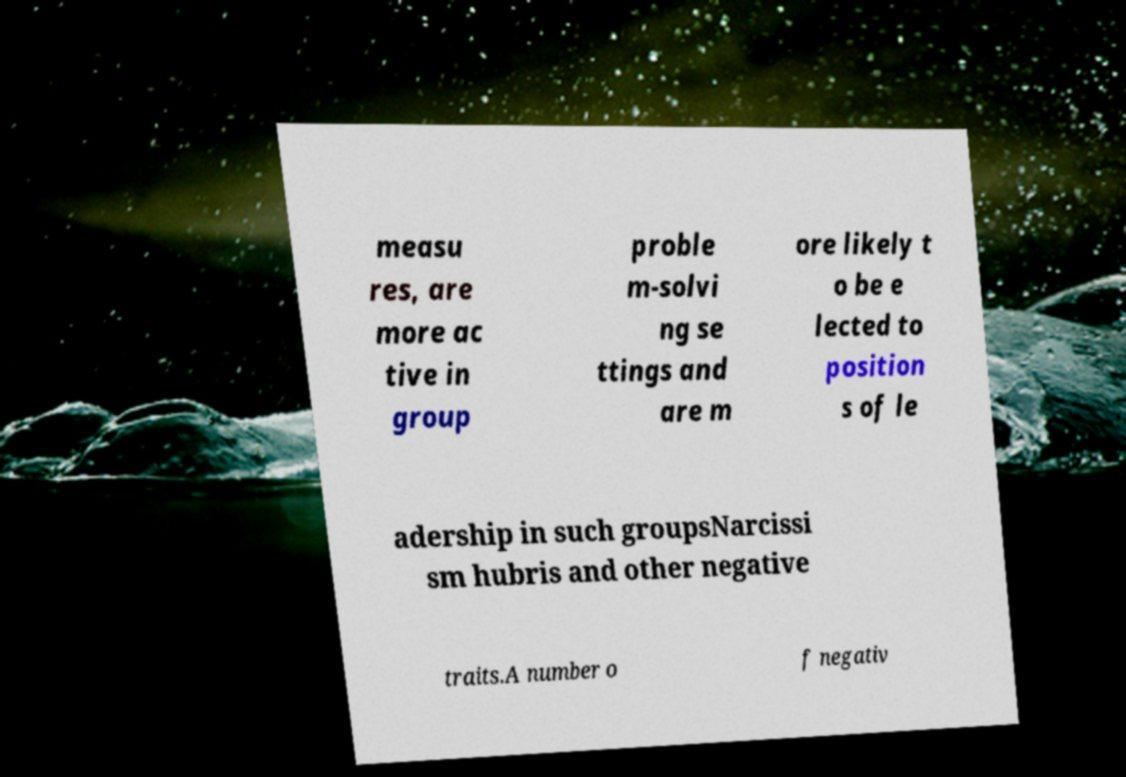Can you accurately transcribe the text from the provided image for me? measu res, are more ac tive in group proble m-solvi ng se ttings and are m ore likely t o be e lected to position s of le adership in such groupsNarcissi sm hubris and other negative traits.A number o f negativ 